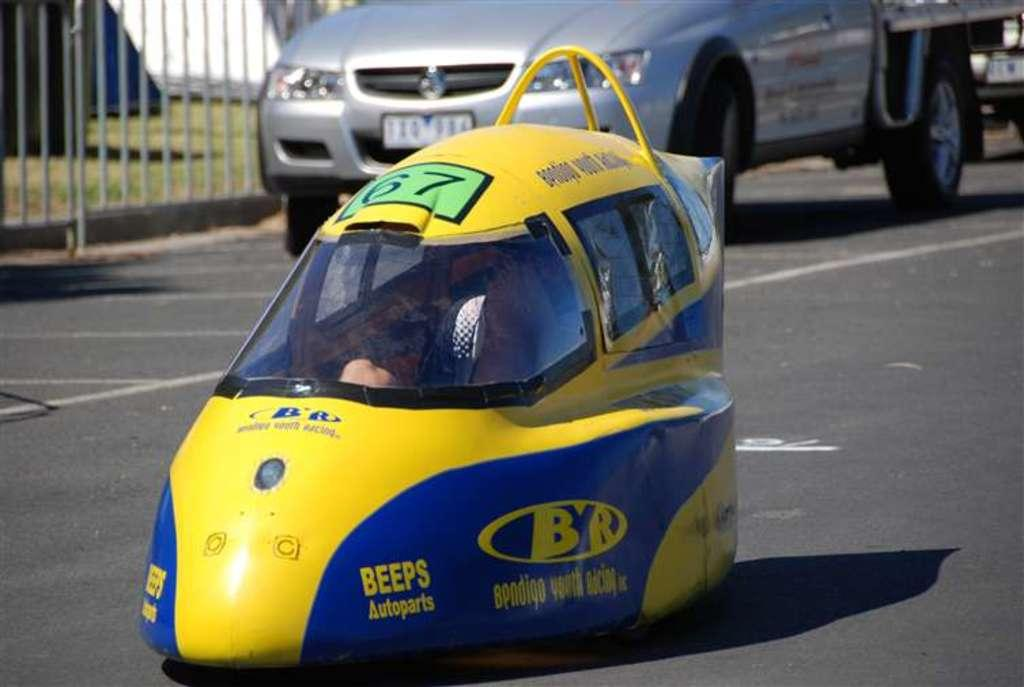<image>
Offer a succinct explanation of the picture presented. a vehicle in the road that is super small with BEEPS Autoparts Bendigo Youth Racing on it. 